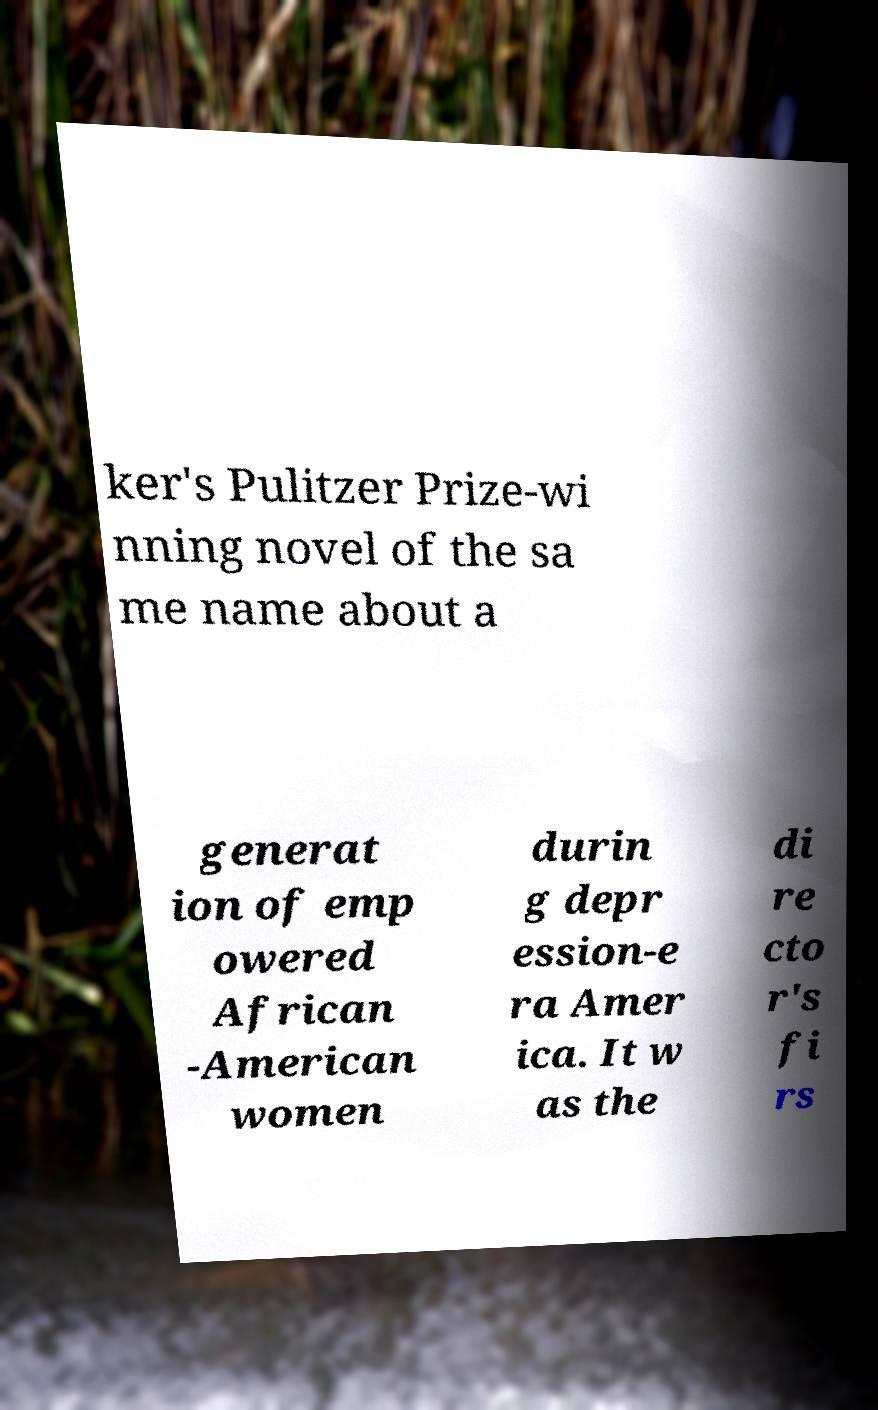For documentation purposes, I need the text within this image transcribed. Could you provide that? ker's Pulitzer Prize-wi nning novel of the sa me name about a generat ion of emp owered African -American women durin g depr ession-e ra Amer ica. It w as the di re cto r's fi rs 